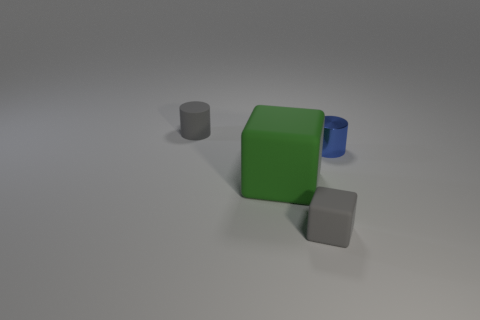There is a small rubber object behind the gray block; is it the same color as the tiny cube?
Your response must be concise. Yes. There is a tiny metal object; are there any big green blocks in front of it?
Give a very brief answer. Yes. The tiny thing that is to the left of the small shiny thing and behind the small cube is what color?
Make the answer very short. Gray. There is a object that is the same color as the matte cylinder; what is its shape?
Make the answer very short. Cube. There is a cube that is to the left of the tiny gray thing that is to the right of the tiny gray rubber cylinder; how big is it?
Provide a short and direct response. Large. What number of balls are matte things or gray things?
Your response must be concise. 0. The other metal cylinder that is the same size as the gray cylinder is what color?
Give a very brief answer. Blue. What shape is the small gray rubber object that is in front of the thing behind the blue thing?
Give a very brief answer. Cube. There is a matte object that is behind the green rubber object; is it the same size as the green cube?
Your answer should be compact. No. What number of other objects are the same material as the gray cube?
Offer a terse response. 2. 